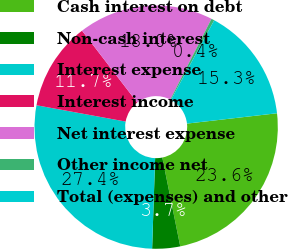Convert chart to OTSL. <chart><loc_0><loc_0><loc_500><loc_500><pie_chart><fcel>Cash interest on debt<fcel>Non-cash interest<fcel>Interest expense<fcel>Interest income<fcel>Net interest expense<fcel>Other income net<fcel>Total (expenses) and other<nl><fcel>23.65%<fcel>3.7%<fcel>27.35%<fcel>11.69%<fcel>17.95%<fcel>0.4%<fcel>15.26%<nl></chart> 